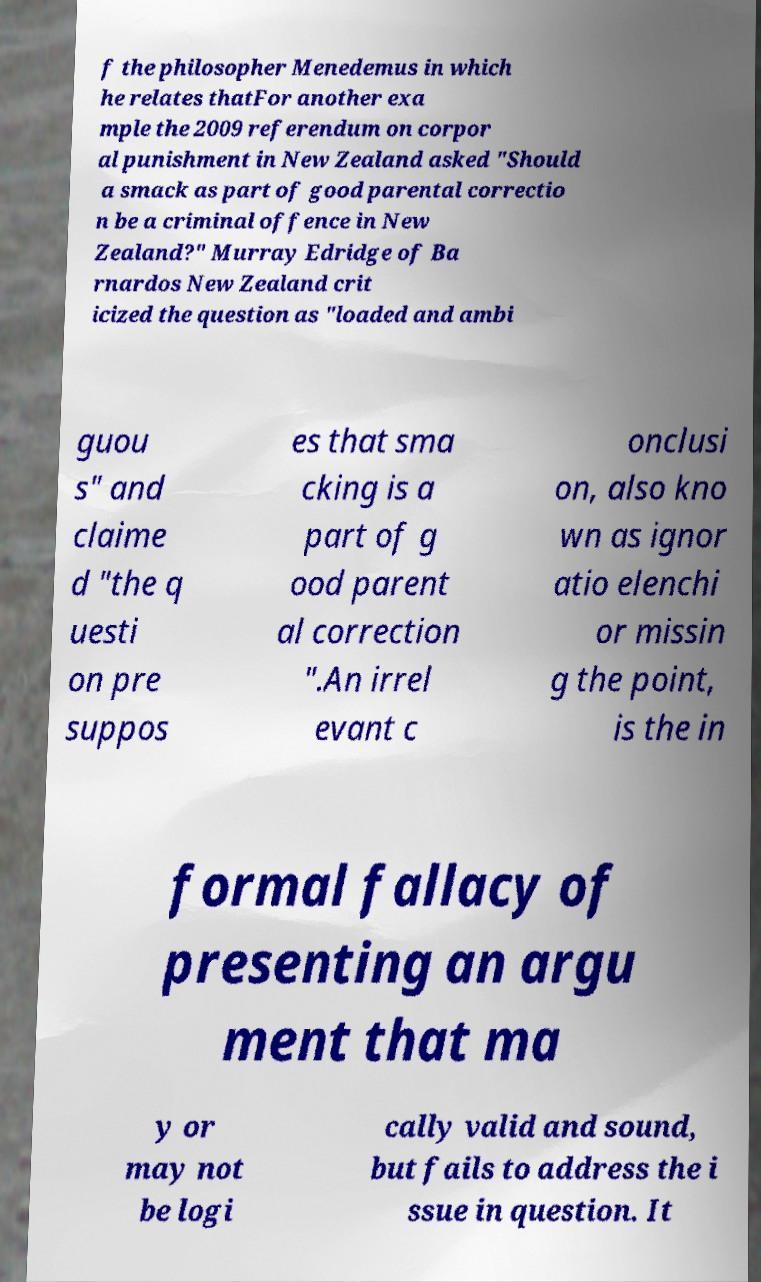Can you accurately transcribe the text from the provided image for me? f the philosopher Menedemus in which he relates thatFor another exa mple the 2009 referendum on corpor al punishment in New Zealand asked "Should a smack as part of good parental correctio n be a criminal offence in New Zealand?" Murray Edridge of Ba rnardos New Zealand crit icized the question as "loaded and ambi guou s" and claime d "the q uesti on pre suppos es that sma cking is a part of g ood parent al correction ".An irrel evant c onclusi on, also kno wn as ignor atio elenchi or missin g the point, is the in formal fallacy of presenting an argu ment that ma y or may not be logi cally valid and sound, but fails to address the i ssue in question. It 